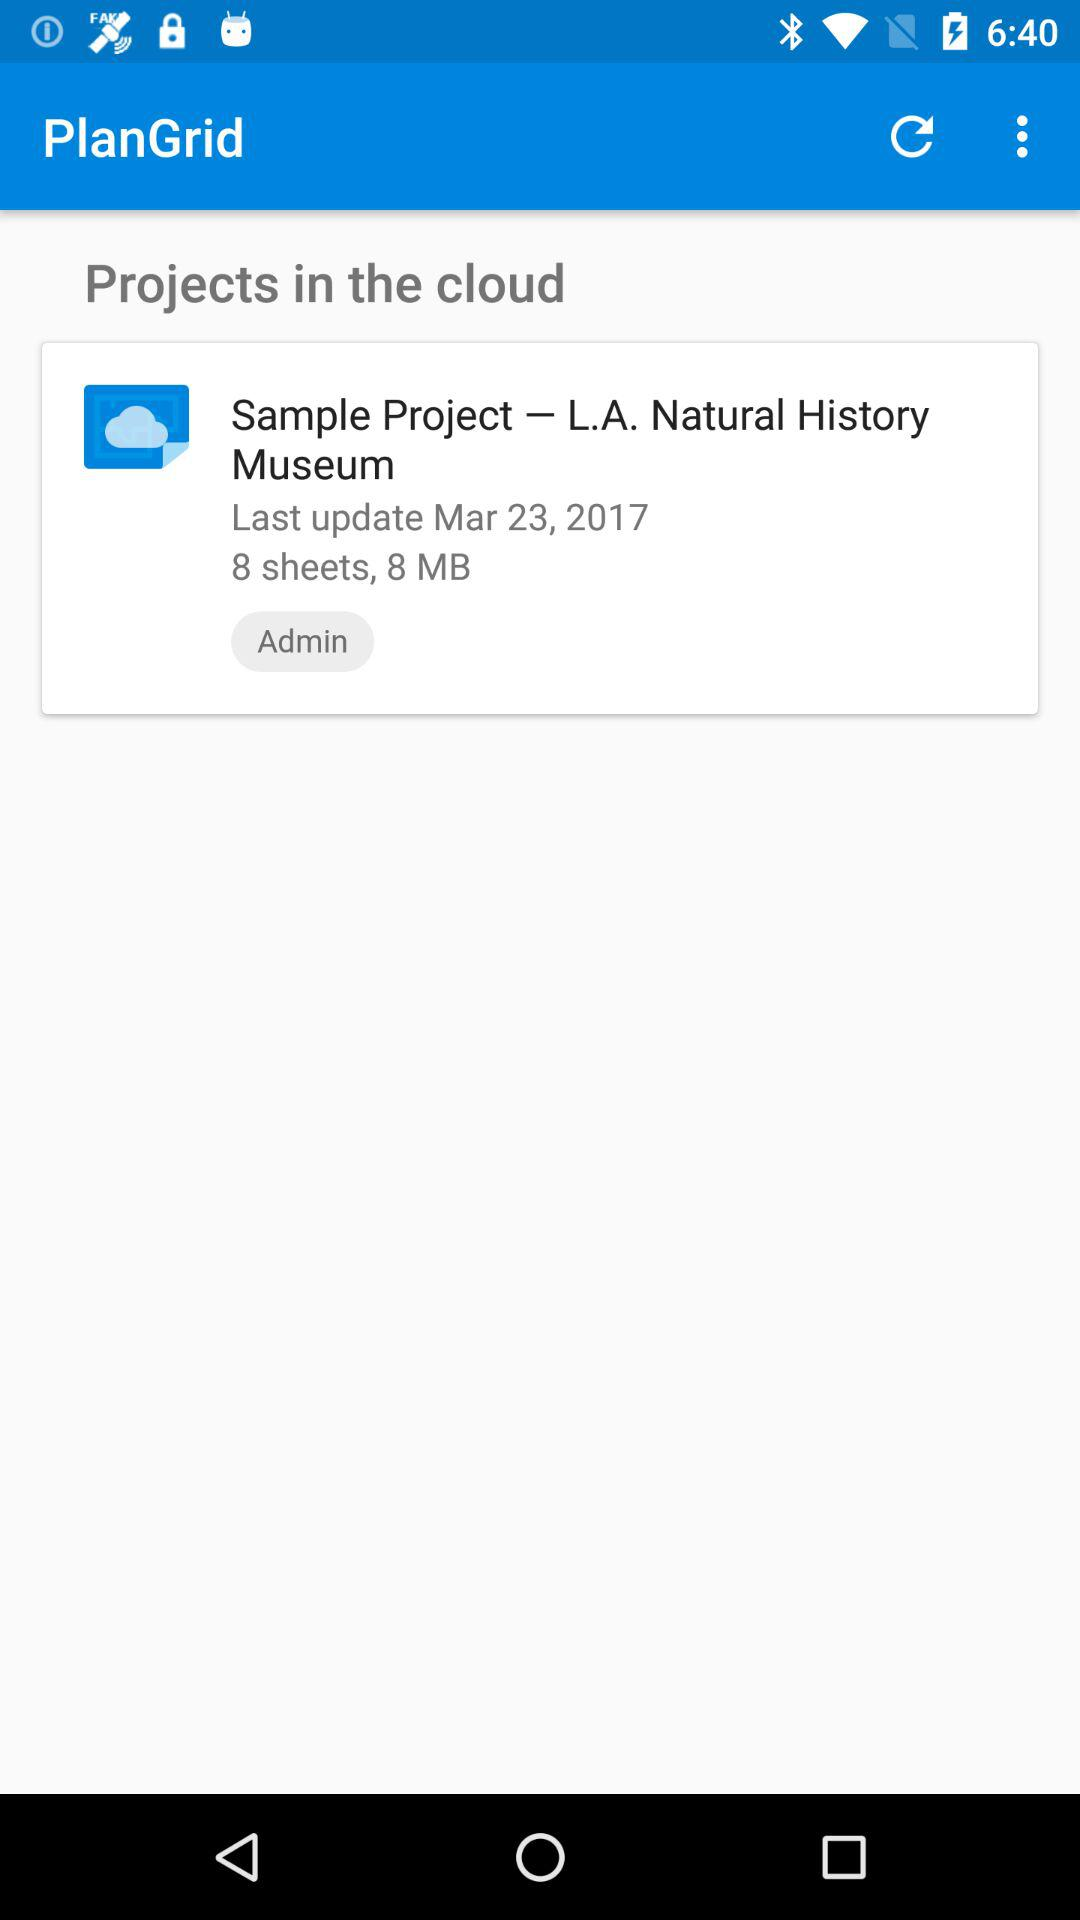How many sheets are in the project?
Answer the question using a single word or phrase. 8 